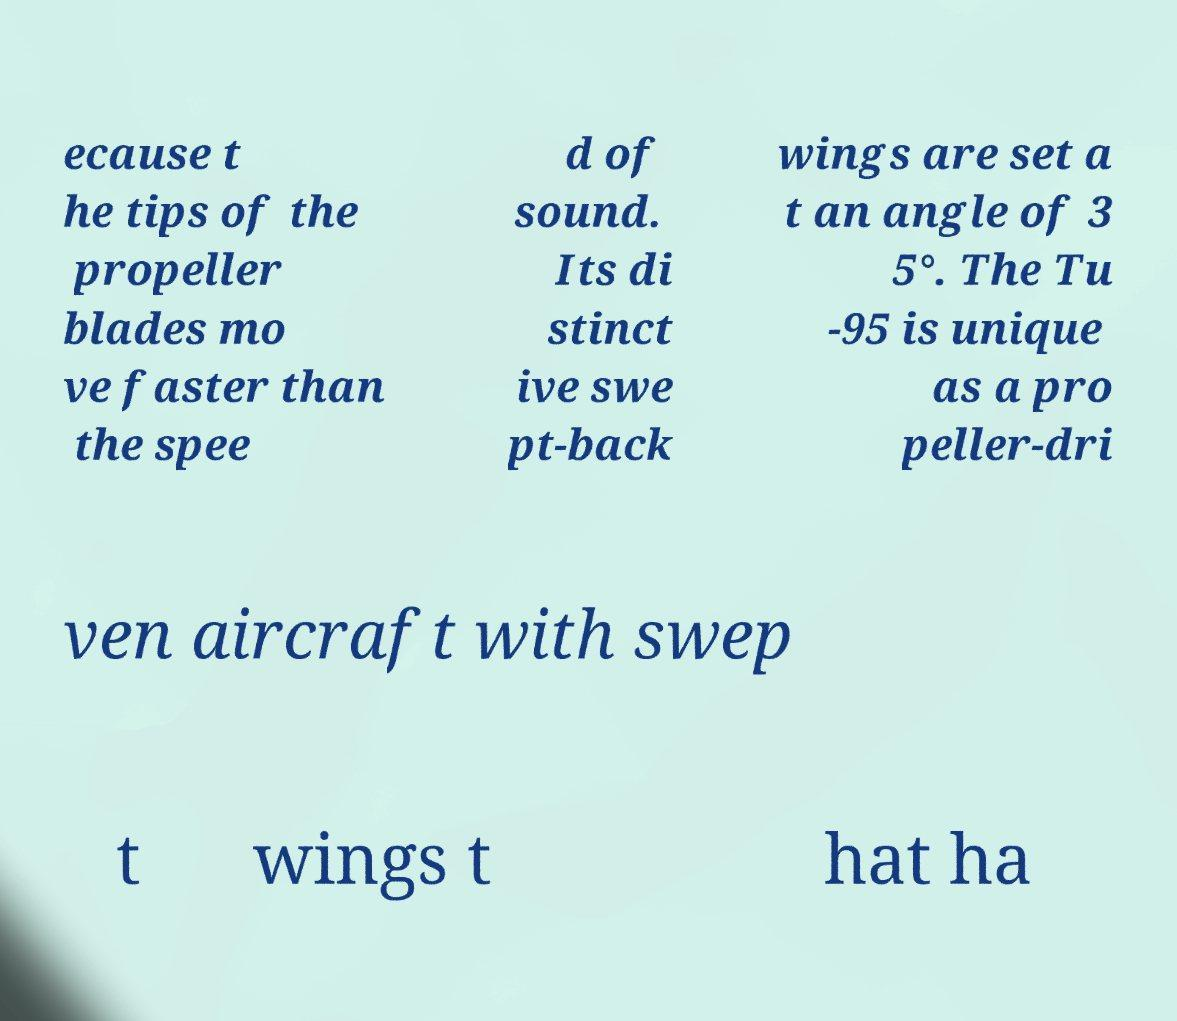Could you assist in decoding the text presented in this image and type it out clearly? ecause t he tips of the propeller blades mo ve faster than the spee d of sound. Its di stinct ive swe pt-back wings are set a t an angle of 3 5°. The Tu -95 is unique as a pro peller-dri ven aircraft with swep t wings t hat ha 